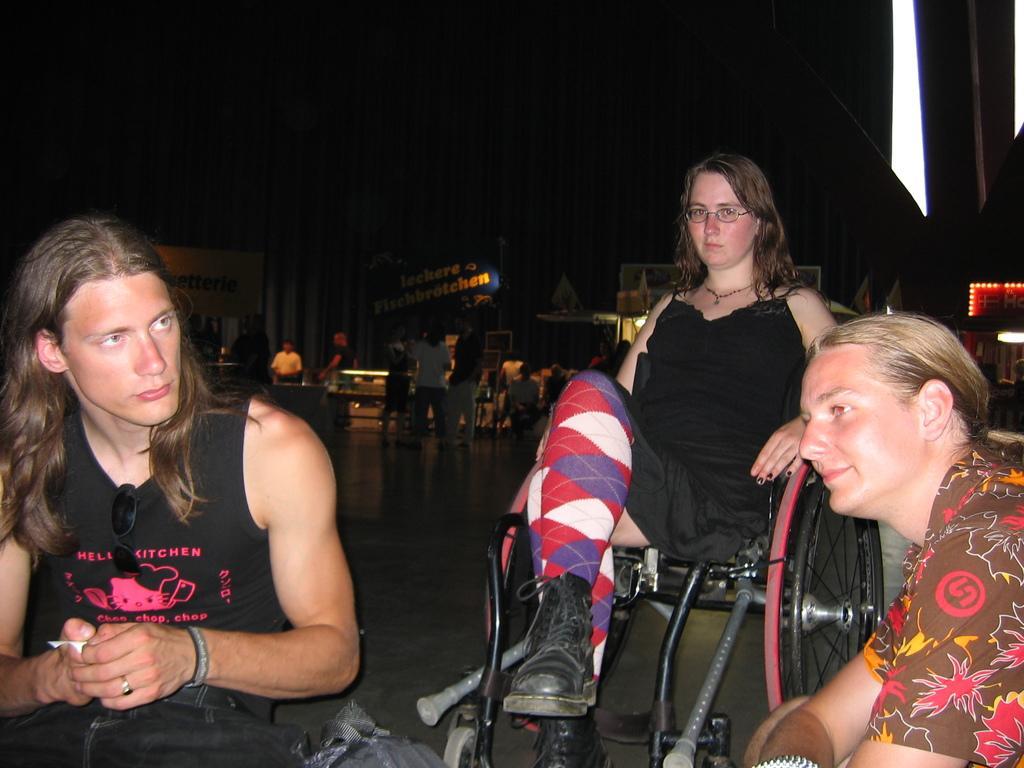In one or two sentences, can you explain what this image depicts? In this image we can see a woman sitting on the wheelchair. We can also see two persons. In the background we can see a few people standing on the floor. Image also consists of banners and also a board with the text and also lights. 